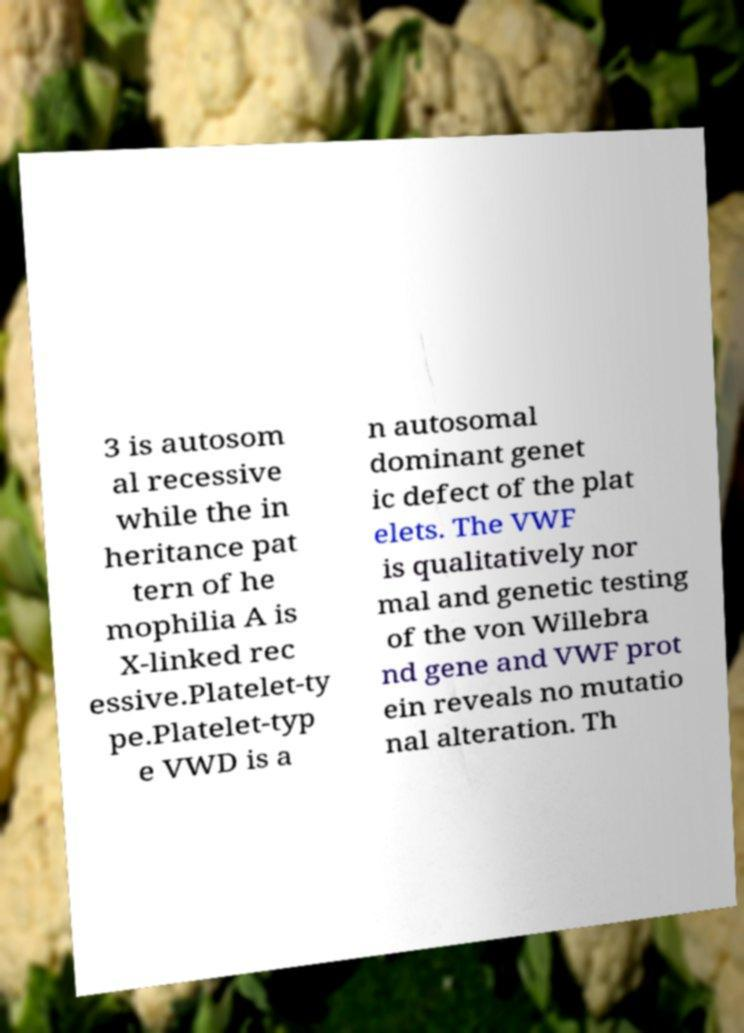Can you read and provide the text displayed in the image?This photo seems to have some interesting text. Can you extract and type it out for me? 3 is autosom al recessive while the in heritance pat tern of he mophilia A is X-linked rec essive.Platelet-ty pe.Platelet-typ e VWD is a n autosomal dominant genet ic defect of the plat elets. The VWF is qualitatively nor mal and genetic testing of the von Willebra nd gene and VWF prot ein reveals no mutatio nal alteration. Th 